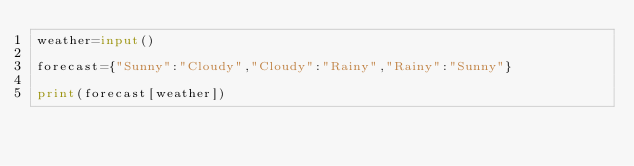Convert code to text. <code><loc_0><loc_0><loc_500><loc_500><_Python_>weather=input()

forecast={"Sunny":"Cloudy","Cloudy":"Rainy","Rainy":"Sunny"}

print(forecast[weather])</code> 